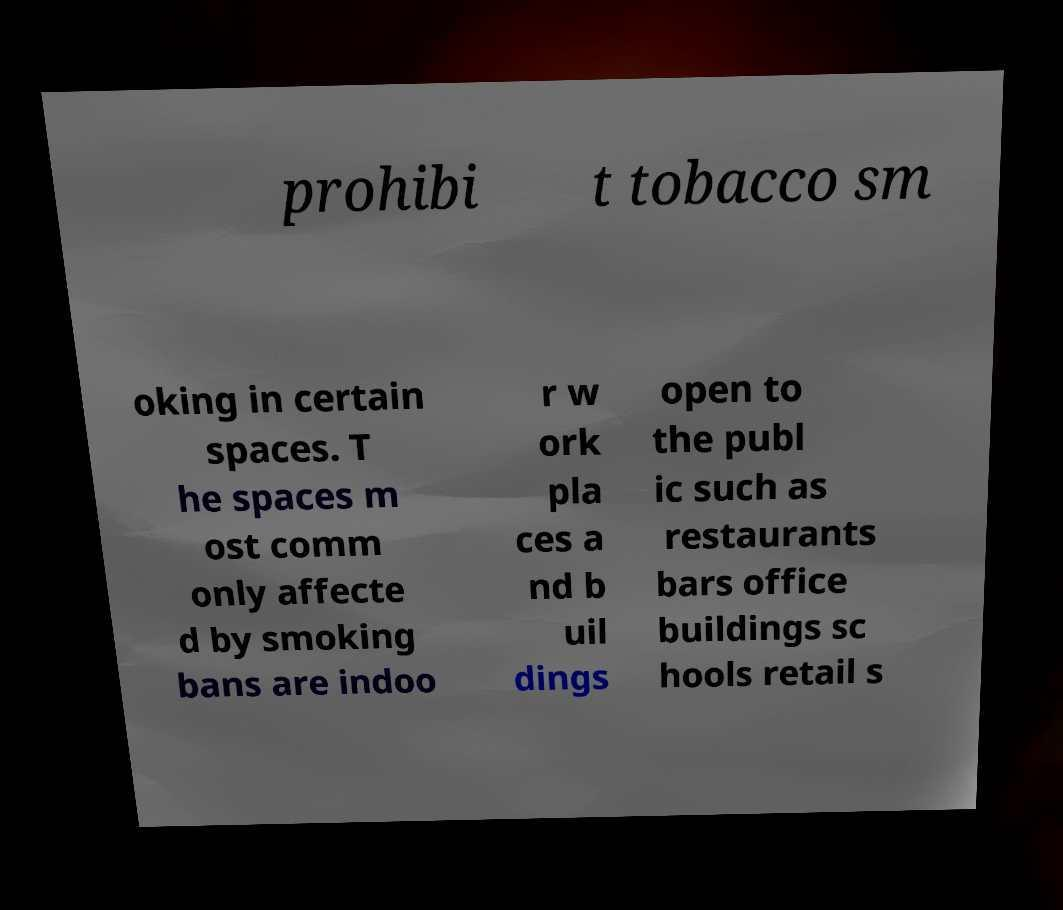There's text embedded in this image that I need extracted. Can you transcribe it verbatim? prohibi t tobacco sm oking in certain spaces. T he spaces m ost comm only affecte d by smoking bans are indoo r w ork pla ces a nd b uil dings open to the publ ic such as restaurants bars office buildings sc hools retail s 